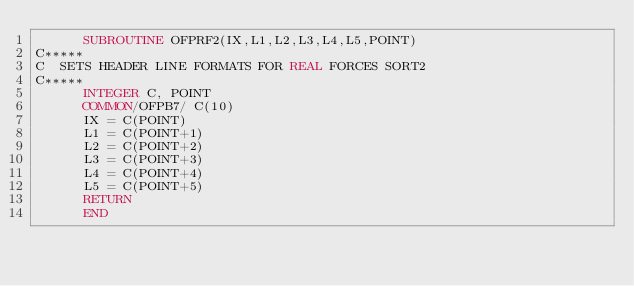<code> <loc_0><loc_0><loc_500><loc_500><_FORTRAN_>      SUBROUTINE OFPRF2(IX,L1,L2,L3,L4,L5,POINT)
C*****
C  SETS HEADER LINE FORMATS FOR REAL FORCES SORT2
C*****
      INTEGER C, POINT
      COMMON/OFPB7/ C(10)
      IX = C(POINT)
      L1 = C(POINT+1)
      L2 = C(POINT+2)
      L3 = C(POINT+3)
      L4 = C(POINT+4)
      L5 = C(POINT+5)
      RETURN
      END
</code> 